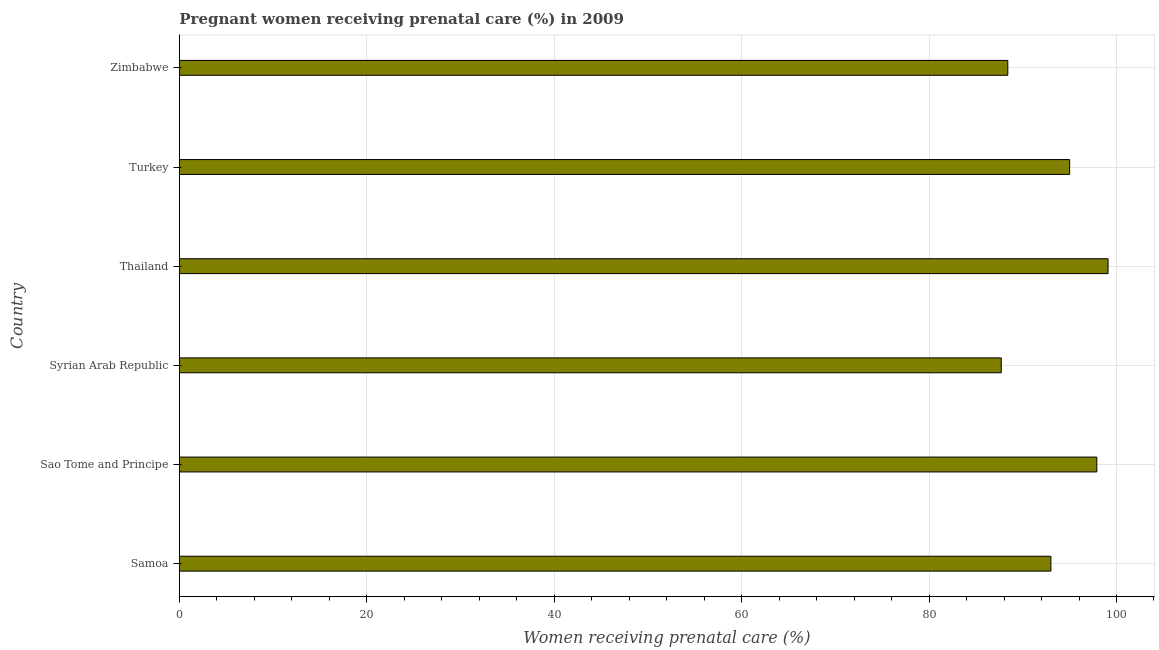What is the title of the graph?
Your answer should be very brief. Pregnant women receiving prenatal care (%) in 2009. What is the label or title of the X-axis?
Ensure brevity in your answer.  Women receiving prenatal care (%). What is the label or title of the Y-axis?
Your response must be concise. Country. What is the percentage of pregnant women receiving prenatal care in Samoa?
Your answer should be very brief. 93. Across all countries, what is the maximum percentage of pregnant women receiving prenatal care?
Make the answer very short. 99.1. Across all countries, what is the minimum percentage of pregnant women receiving prenatal care?
Give a very brief answer. 87.7. In which country was the percentage of pregnant women receiving prenatal care maximum?
Your answer should be very brief. Thailand. In which country was the percentage of pregnant women receiving prenatal care minimum?
Your answer should be compact. Syrian Arab Republic. What is the sum of the percentage of pregnant women receiving prenatal care?
Offer a very short reply. 561.1. What is the average percentage of pregnant women receiving prenatal care per country?
Provide a short and direct response. 93.52. What is the median percentage of pregnant women receiving prenatal care?
Make the answer very short. 94. In how many countries, is the percentage of pregnant women receiving prenatal care greater than 56 %?
Ensure brevity in your answer.  6. Is the percentage of pregnant women receiving prenatal care in Samoa less than that in Thailand?
Give a very brief answer. Yes. What is the difference between the highest and the second highest percentage of pregnant women receiving prenatal care?
Provide a short and direct response. 1.2. How many countries are there in the graph?
Your response must be concise. 6. What is the difference between two consecutive major ticks on the X-axis?
Your answer should be compact. 20. Are the values on the major ticks of X-axis written in scientific E-notation?
Give a very brief answer. No. What is the Women receiving prenatal care (%) in Samoa?
Ensure brevity in your answer.  93. What is the Women receiving prenatal care (%) of Sao Tome and Principe?
Provide a succinct answer. 97.9. What is the Women receiving prenatal care (%) of Syrian Arab Republic?
Your answer should be compact. 87.7. What is the Women receiving prenatal care (%) in Thailand?
Your answer should be very brief. 99.1. What is the Women receiving prenatal care (%) in Turkey?
Make the answer very short. 95. What is the Women receiving prenatal care (%) in Zimbabwe?
Make the answer very short. 88.4. What is the difference between the Women receiving prenatal care (%) in Samoa and Syrian Arab Republic?
Ensure brevity in your answer.  5.3. What is the difference between the Women receiving prenatal care (%) in Samoa and Thailand?
Keep it short and to the point. -6.1. What is the difference between the Women receiving prenatal care (%) in Samoa and Turkey?
Your response must be concise. -2. What is the difference between the Women receiving prenatal care (%) in Samoa and Zimbabwe?
Provide a short and direct response. 4.6. What is the difference between the Women receiving prenatal care (%) in Sao Tome and Principe and Syrian Arab Republic?
Provide a succinct answer. 10.2. What is the difference between the Women receiving prenatal care (%) in Sao Tome and Principe and Thailand?
Your answer should be very brief. -1.2. What is the difference between the Women receiving prenatal care (%) in Sao Tome and Principe and Zimbabwe?
Provide a short and direct response. 9.5. What is the difference between the Women receiving prenatal care (%) in Syrian Arab Republic and Thailand?
Your answer should be very brief. -11.4. What is the difference between the Women receiving prenatal care (%) in Thailand and Zimbabwe?
Provide a succinct answer. 10.7. What is the difference between the Women receiving prenatal care (%) in Turkey and Zimbabwe?
Make the answer very short. 6.6. What is the ratio of the Women receiving prenatal care (%) in Samoa to that in Sao Tome and Principe?
Provide a short and direct response. 0.95. What is the ratio of the Women receiving prenatal care (%) in Samoa to that in Syrian Arab Republic?
Provide a succinct answer. 1.06. What is the ratio of the Women receiving prenatal care (%) in Samoa to that in Thailand?
Give a very brief answer. 0.94. What is the ratio of the Women receiving prenatal care (%) in Samoa to that in Zimbabwe?
Ensure brevity in your answer.  1.05. What is the ratio of the Women receiving prenatal care (%) in Sao Tome and Principe to that in Syrian Arab Republic?
Keep it short and to the point. 1.12. What is the ratio of the Women receiving prenatal care (%) in Sao Tome and Principe to that in Thailand?
Provide a short and direct response. 0.99. What is the ratio of the Women receiving prenatal care (%) in Sao Tome and Principe to that in Turkey?
Provide a succinct answer. 1.03. What is the ratio of the Women receiving prenatal care (%) in Sao Tome and Principe to that in Zimbabwe?
Your answer should be very brief. 1.11. What is the ratio of the Women receiving prenatal care (%) in Syrian Arab Republic to that in Thailand?
Your answer should be compact. 0.89. What is the ratio of the Women receiving prenatal care (%) in Syrian Arab Republic to that in Turkey?
Your response must be concise. 0.92. What is the ratio of the Women receiving prenatal care (%) in Syrian Arab Republic to that in Zimbabwe?
Keep it short and to the point. 0.99. What is the ratio of the Women receiving prenatal care (%) in Thailand to that in Turkey?
Ensure brevity in your answer.  1.04. What is the ratio of the Women receiving prenatal care (%) in Thailand to that in Zimbabwe?
Your response must be concise. 1.12. What is the ratio of the Women receiving prenatal care (%) in Turkey to that in Zimbabwe?
Ensure brevity in your answer.  1.07. 